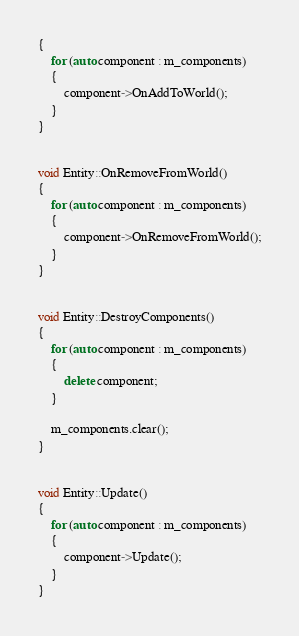<code> <loc_0><loc_0><loc_500><loc_500><_C++_>{
	for (auto component : m_components)
	{
		component->OnAddToWorld();
	}
}


void Entity::OnRemoveFromWorld()
{
	for (auto component : m_components)
	{
		component->OnRemoveFromWorld();
	}
}


void Entity::DestroyComponents()
{
	for (auto component : m_components)
	{
		delete component;
	}

	m_components.clear();
}


void Entity::Update()
{
	for (auto component : m_components)
	{
		component->Update();
	}
}





</code> 